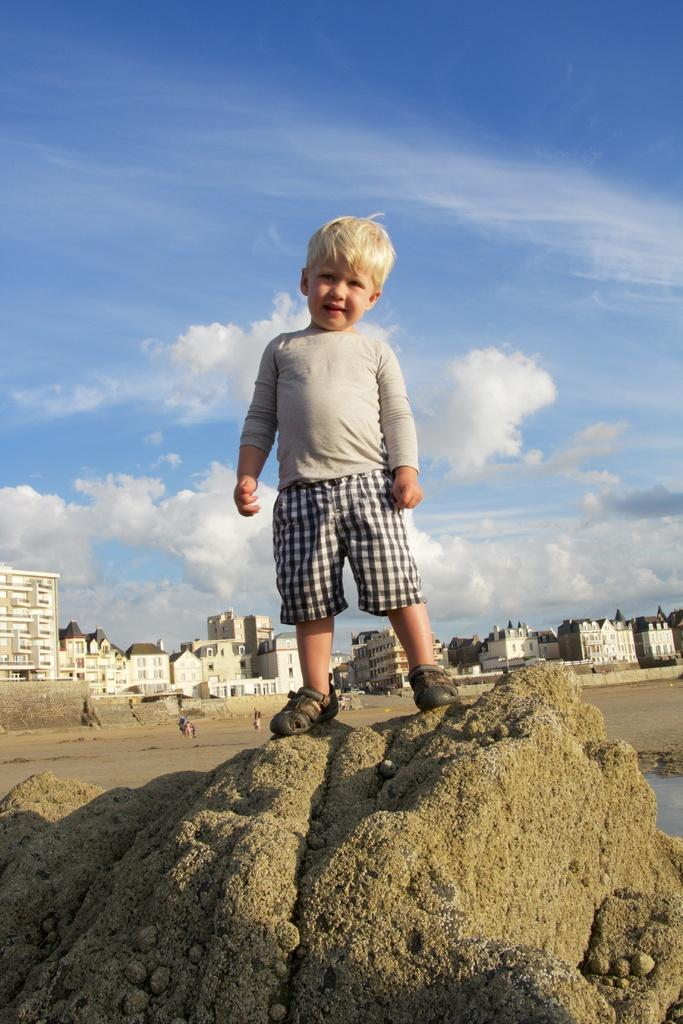What is the main subject of the image? The main subject of the image is a kid. Where is the kid located in the image? The kid is on a rock in the image. What can be seen in the background of the image? There are buildings and people in the background of the image. What natural element is visible in the image? There is water visible in the image. What is the condition of the sky in the image? The sky is visible at the top of the image, and there are clouds present. What type of cap is the mother wearing in the image? There is no mother or cap present in the image; it features a kid on a rock with buildings, people, water, and clouds in the sky. 